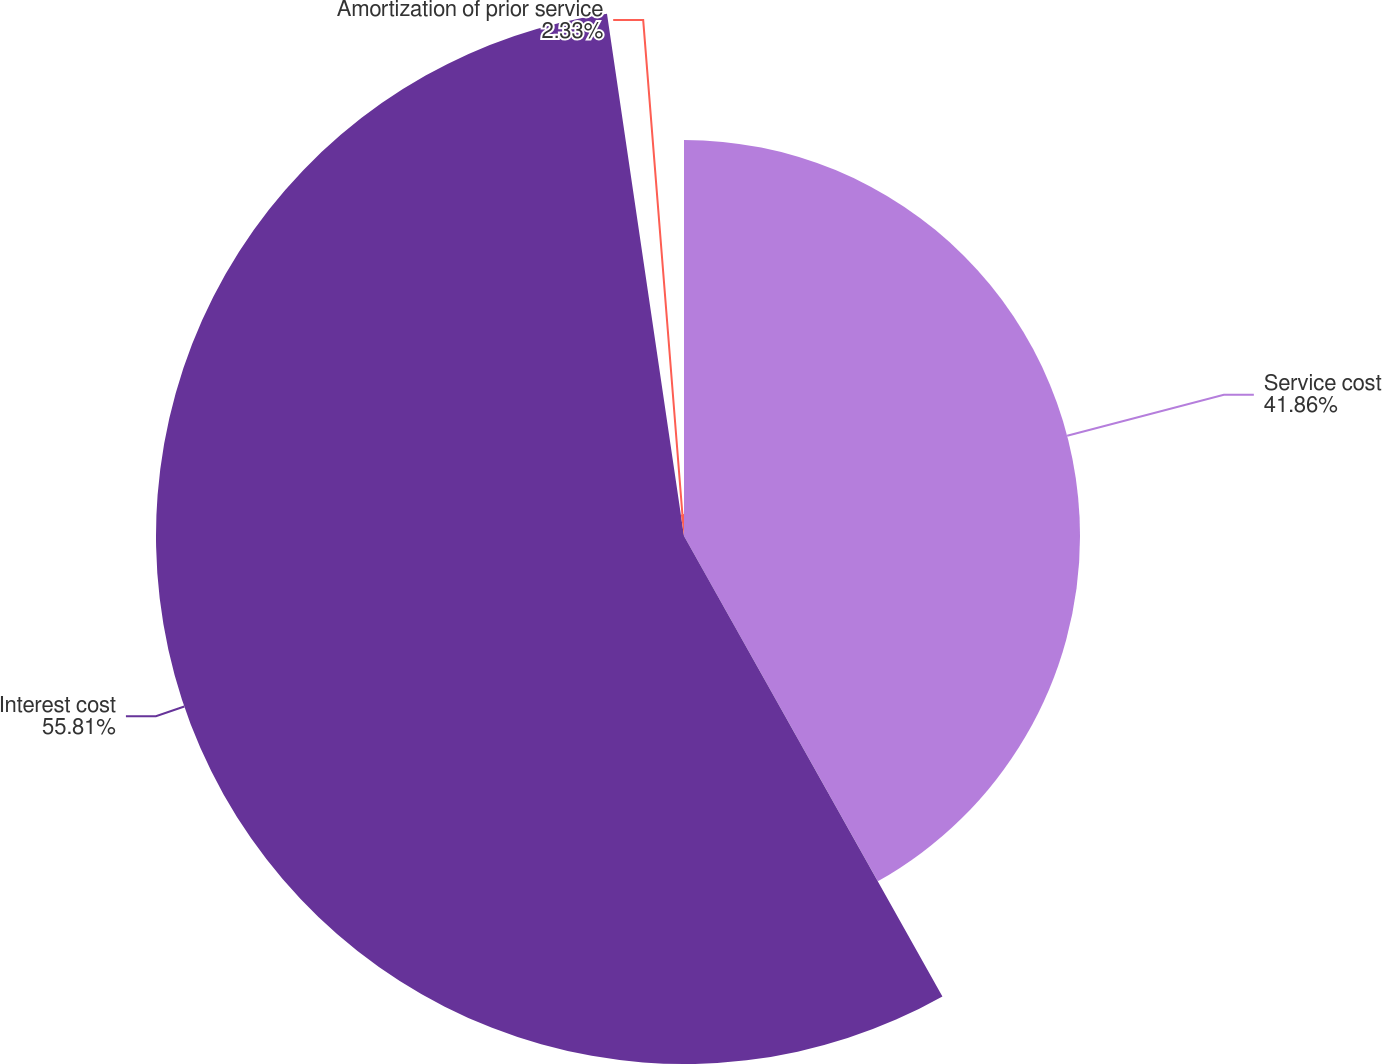Convert chart to OTSL. <chart><loc_0><loc_0><loc_500><loc_500><pie_chart><fcel>Service cost<fcel>Interest cost<fcel>Amortization of prior service<nl><fcel>41.86%<fcel>55.81%<fcel>2.33%<nl></chart> 